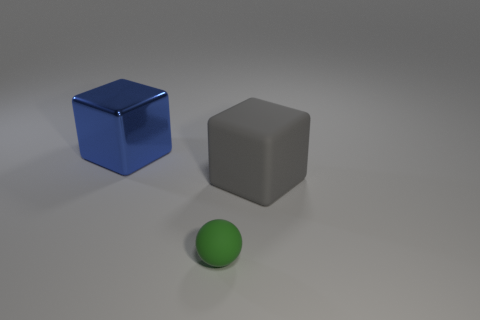What can you infer about the environment surrounding the objects? The environment is simplistic and nondescript, likely a studio setting with a neutral gray background that focuses attention solely on the three objects. 